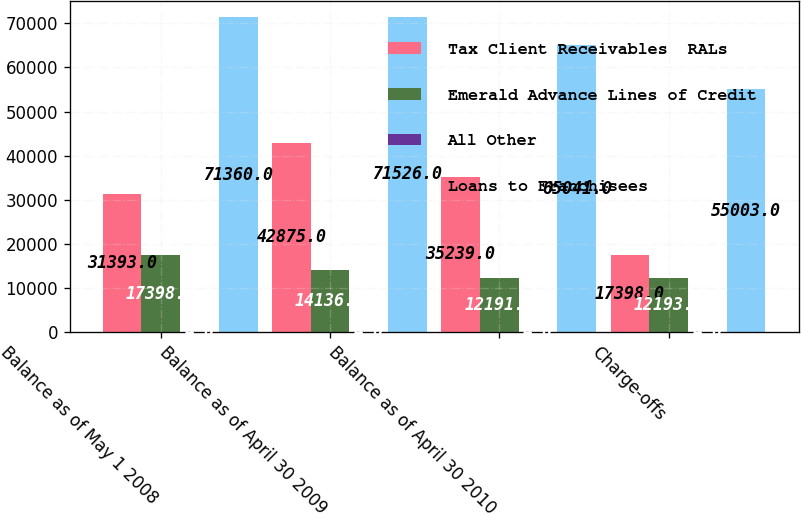Convert chart to OTSL. <chart><loc_0><loc_0><loc_500><loc_500><stacked_bar_chart><ecel><fcel>Balance as of May 1 2008<fcel>Balance as of April 30 2009<fcel>Balance as of April 30 2010<fcel>Charge-offs<nl><fcel>Tax Client Receivables  RALs<fcel>31393<fcel>42875<fcel>35239<fcel>17398<nl><fcel>Emerald Advance Lines of Credit<fcel>17398<fcel>14136<fcel>12191<fcel>12193<nl><fcel>All Other<fcel>4<fcel>4<fcel>4<fcel>4<nl><fcel>Loans to Franchisees<fcel>71360<fcel>71526<fcel>65041<fcel>55003<nl></chart> 